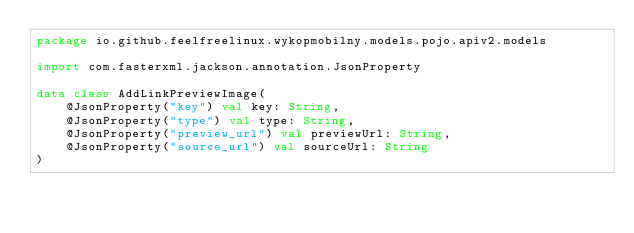<code> <loc_0><loc_0><loc_500><loc_500><_Kotlin_>package io.github.feelfreelinux.wykopmobilny.models.pojo.apiv2.models

import com.fasterxml.jackson.annotation.JsonProperty

data class AddLinkPreviewImage(
    @JsonProperty("key") val key: String,
    @JsonProperty("type") val type: String,
    @JsonProperty("preview_url") val previewUrl: String,
    @JsonProperty("source_url") val sourceUrl: String
)</code> 